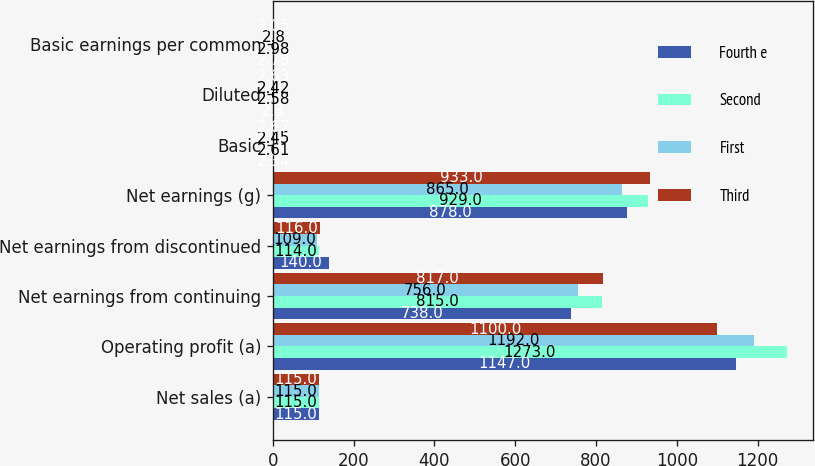<chart> <loc_0><loc_0><loc_500><loc_500><stacked_bar_chart><ecel><fcel>Net sales (a)<fcel>Operating profit (a)<fcel>Net earnings from continuing<fcel>Net earnings from discontinued<fcel>Net earnings (g)<fcel>Basic<fcel>Diluted<fcel>Basic earnings per common<nl><fcel>Fourth e<fcel>115<fcel>1147<fcel>738<fcel>140<fcel>878<fcel>2.34<fcel>2.3<fcel>2.78<nl><fcel>Second<fcel>115<fcel>1273<fcel>815<fcel>114<fcel>929<fcel>2.61<fcel>2.58<fcel>2.98<nl><fcel>First<fcel>115<fcel>1192<fcel>756<fcel>109<fcel>865<fcel>2.45<fcel>2.42<fcel>2.8<nl><fcel>Third<fcel>115<fcel>1100<fcel>817<fcel>116<fcel>933<fcel>2.67<fcel>2.63<fcel>3.05<nl></chart> 